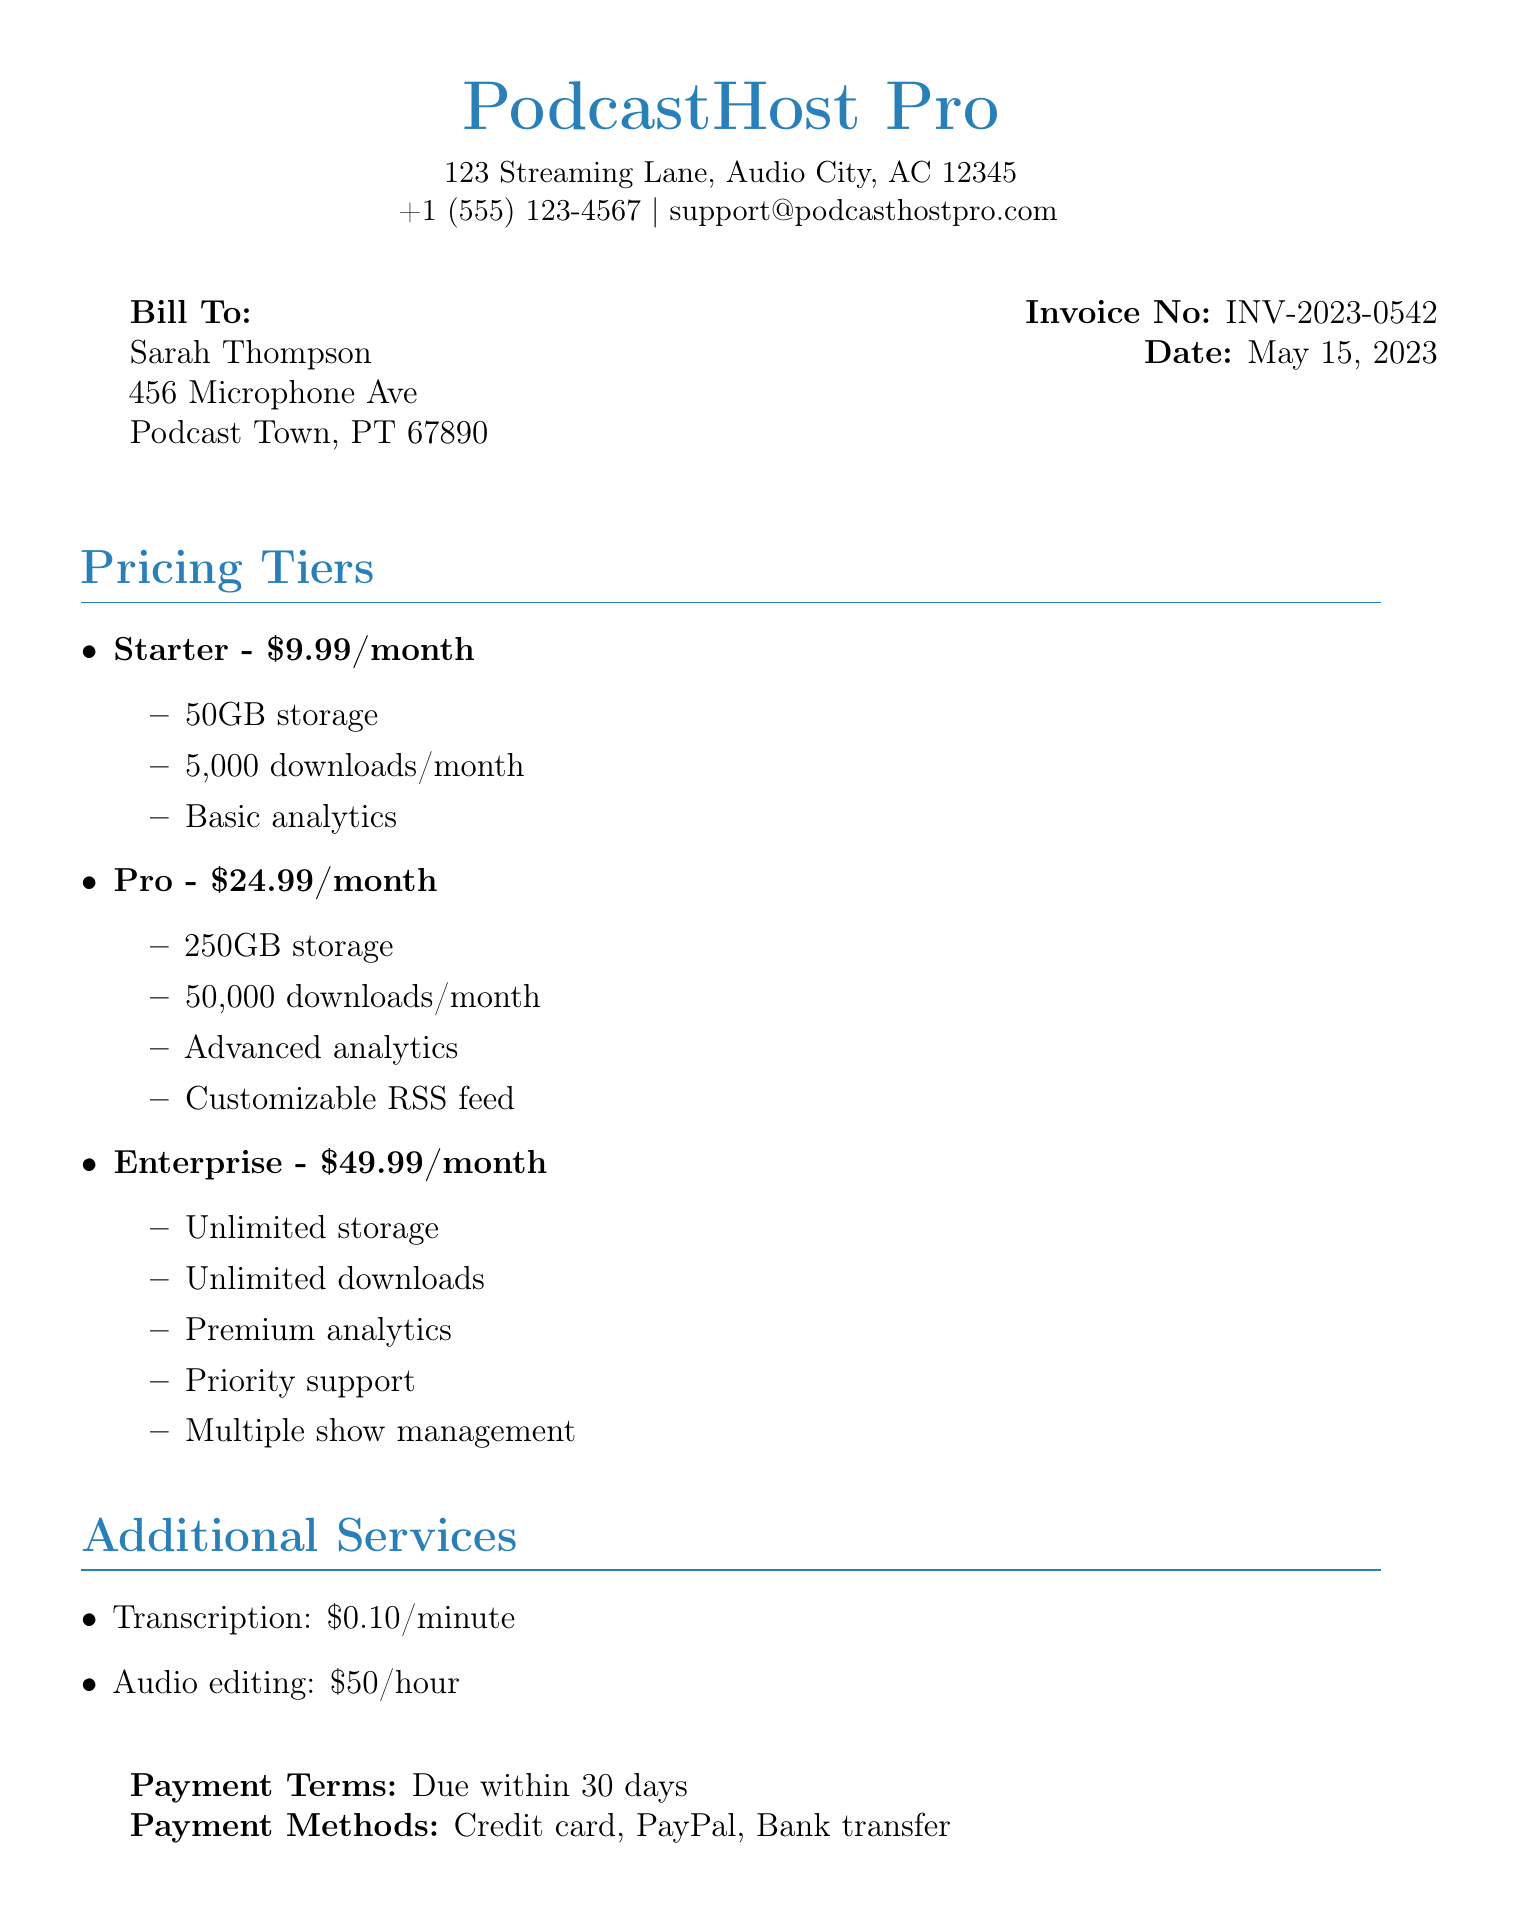What is the invoice number? The invoice number is a unique identifier for the billing document mentioned in the header.
Answer: INV-2023-0542 What is the amount for the Pro pricing tier? The Pro pricing tier is specified under the Pricing Tiers section with its corresponding cost.
Answer: $24.99/month How many GB of storage does the Starter plan offer? The Starter plan's storage capacity is clearly stated in the pricing section of the document.
Answer: 50GB When is the payment due? The payment terms specify when the payment should be completed according to the document.
Answer: Within 30 days What is the additional service charge for transcription? The document outlines the costs for additional services and includes the charge for transcription.
Answer: $0.10/minute What is the primary support level for the Enterprise plan? The level of support provided for the Enterprise plan can be found in the description of its features.
Answer: Priority support Who is the invoice billed to? The document includes a section specifying the individual's name and address to whom the invoice is directed.
Answer: Sarah Thompson What is the address of PodcastHost Pro? The address of the company is listed at the top of the invoice, which is relevant for identification.
Answer: 123 Streaming Lane, Audio City, AC 12345 Which payment methods are accepted? The document includes a section that lists the different ways in which payments can be made.
Answer: Credit card, PayPal, Bank transfer 